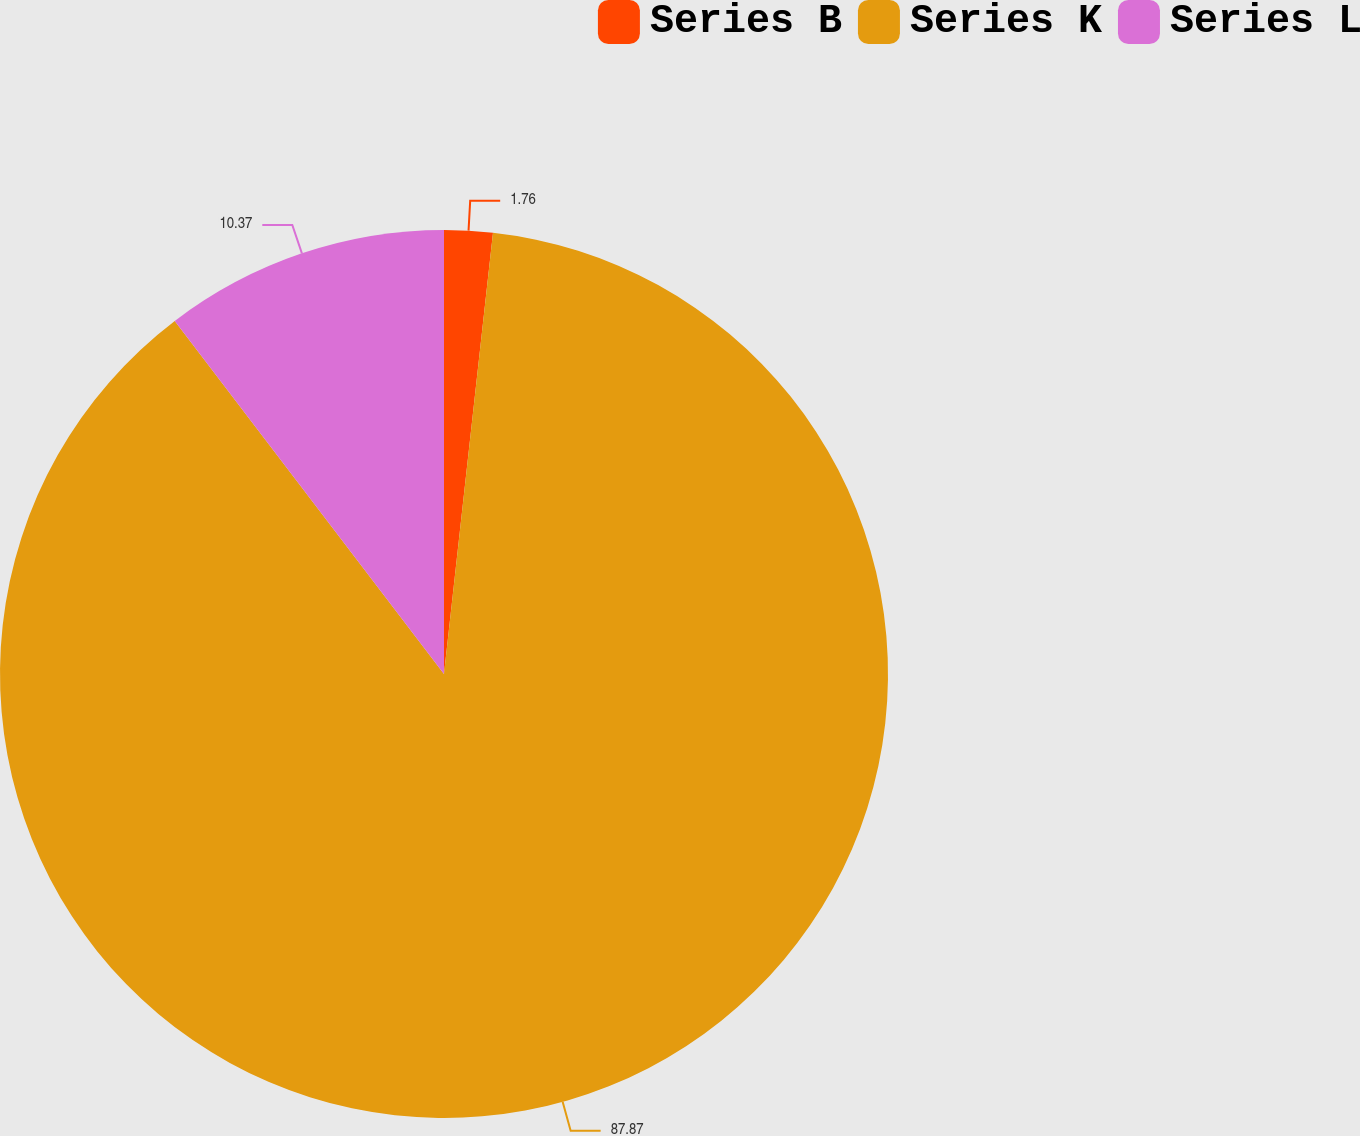Convert chart. <chart><loc_0><loc_0><loc_500><loc_500><pie_chart><fcel>Series B<fcel>Series K<fcel>Series L<nl><fcel>1.76%<fcel>87.87%<fcel>10.37%<nl></chart> 